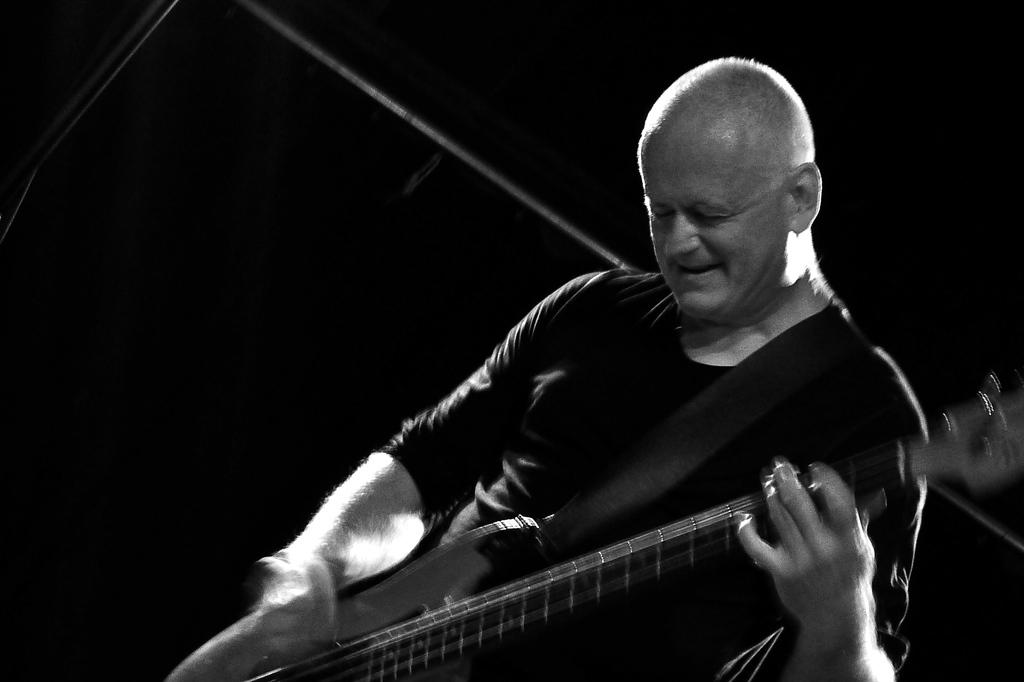What is the color scheme of the image? The image is black and white. What is the man in the image doing? The man is playing the guitar in the image. What can be seen in the background of the image? There are rods in the background of the image. What color is the background of the image? The background is in black color. What type of canvas is the man using to play chess in the image? There is no canvas or chess game present in the image; it features a man playing the guitar in a black and white setting with rods in the background. 